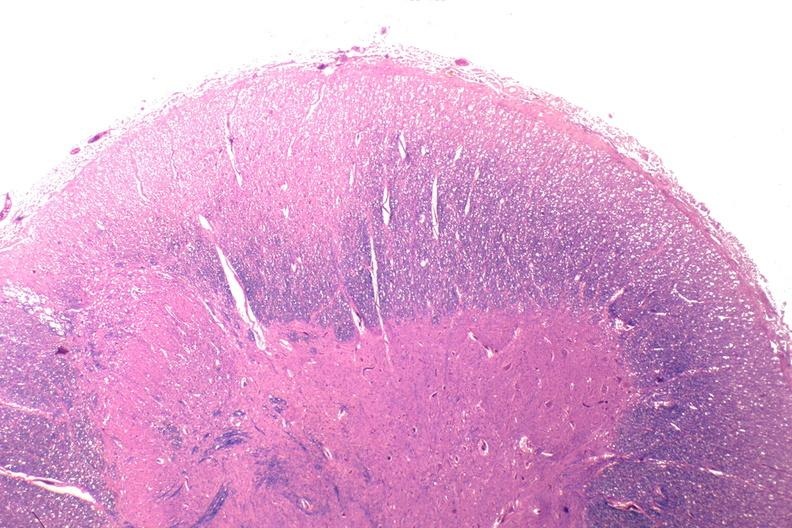what is present?
Answer the question using a single word or phrase. Nervous 